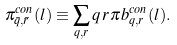<formula> <loc_0><loc_0><loc_500><loc_500>\pi ^ { c o n } _ { \bar { q } , \bar { r } } ( l ) \equiv \sum _ { q , r } q \, r \, \pi b ^ { c o n } _ { q , r } ( l ) .</formula> 